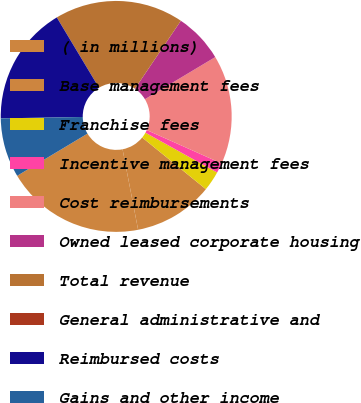<chart> <loc_0><loc_0><loc_500><loc_500><pie_chart><fcel>( in millions)<fcel>Base management fees<fcel>Franchise fees<fcel>Incentive management fees<fcel>Cost reimbursements<fcel>Owned leased corporate housing<fcel>Total revenue<fcel>General administrative and<fcel>Reimbursed costs<fcel>Gains and other income<nl><fcel>19.44%<fcel>11.11%<fcel>2.78%<fcel>1.39%<fcel>15.27%<fcel>6.95%<fcel>18.05%<fcel>0.01%<fcel>16.66%<fcel>8.33%<nl></chart> 